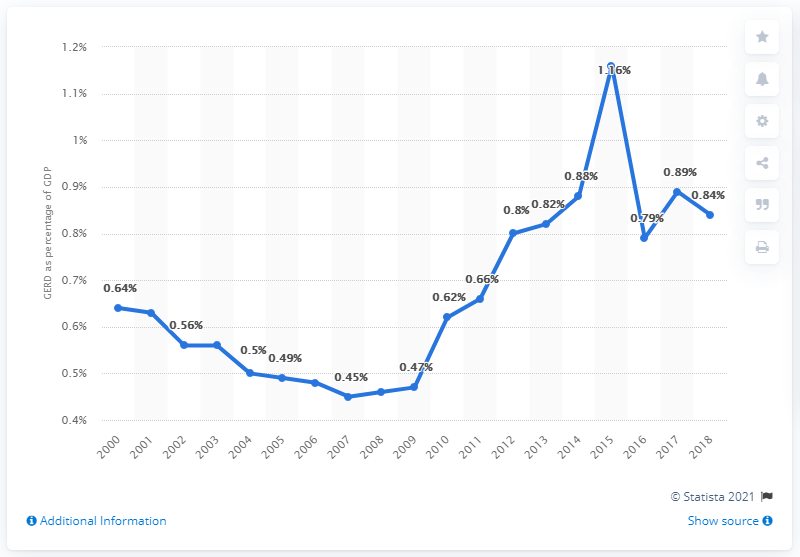Give some essential details in this illustration. In 2018, Slovakia's share of GERD was 0.84%. 